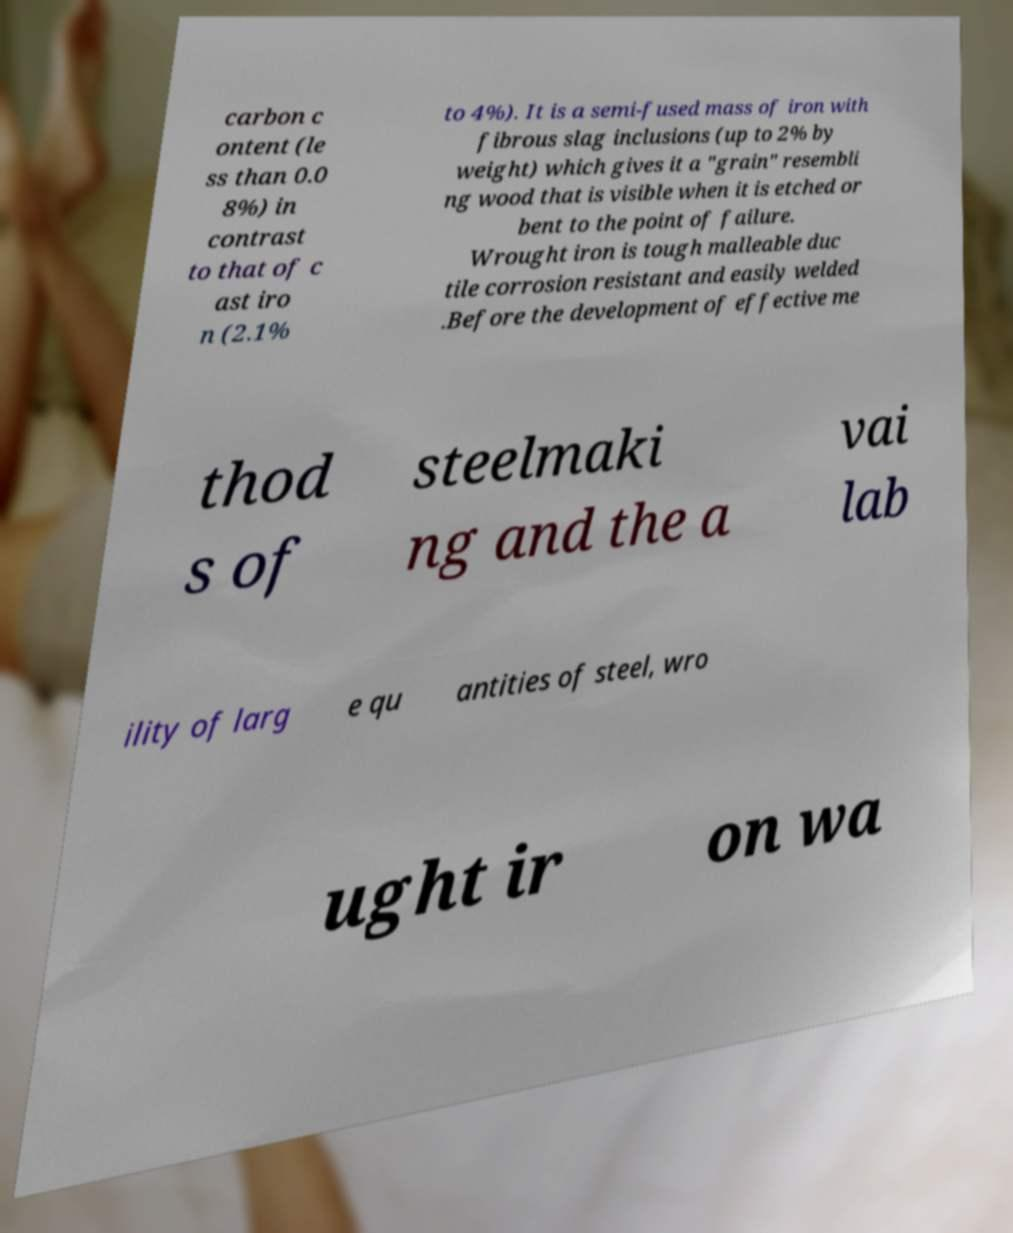What messages or text are displayed in this image? I need them in a readable, typed format. carbon c ontent (le ss than 0.0 8%) in contrast to that of c ast iro n (2.1% to 4%). It is a semi-fused mass of iron with fibrous slag inclusions (up to 2% by weight) which gives it a "grain" resembli ng wood that is visible when it is etched or bent to the point of failure. Wrought iron is tough malleable duc tile corrosion resistant and easily welded .Before the development of effective me thod s of steelmaki ng and the a vai lab ility of larg e qu antities of steel, wro ught ir on wa 